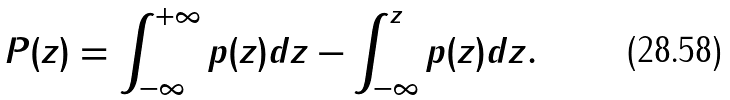Convert formula to latex. <formula><loc_0><loc_0><loc_500><loc_500>P ( z ) = \int ^ { + \infty } _ { - \infty } p ( z ) d z - \int ^ { z } _ { - \infty } p ( z ) d z .</formula> 